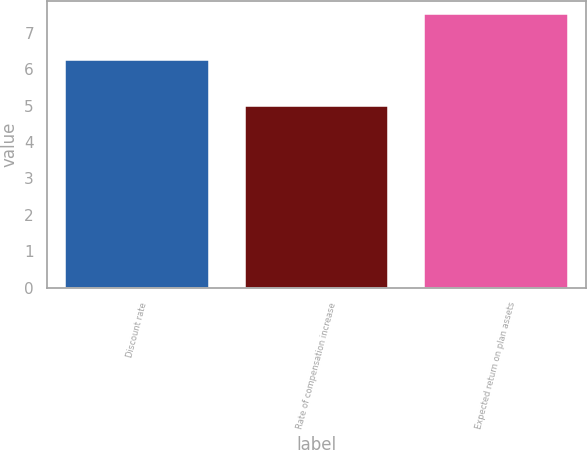<chart> <loc_0><loc_0><loc_500><loc_500><bar_chart><fcel>Discount rate<fcel>Rate of compensation increase<fcel>Expected return on plan assets<nl><fcel>6.25<fcel>5<fcel>7.5<nl></chart> 